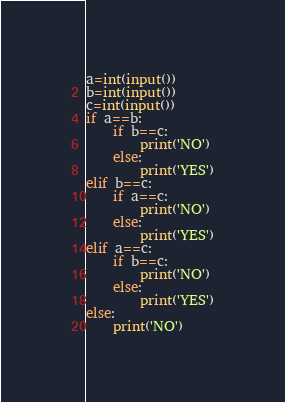<code> <loc_0><loc_0><loc_500><loc_500><_Python_>a=int(input())
b=int(input())
c=int(input())
if a==b:
    if b==c: 
        print('NO')
    else:
        print('YES')
elif b==c:
    if a==c: 
        print('NO')
    else:
        print('YES')
elif a==c:
    if b==c:
        print('NO')
    else:
        print('YES')
else:
    print('NO')

</code> 